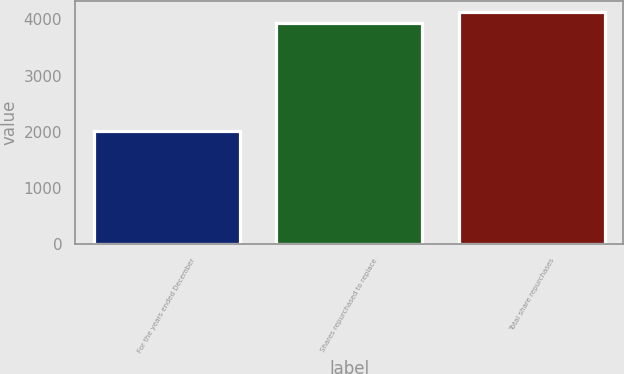<chart> <loc_0><loc_0><loc_500><loc_500><bar_chart><fcel>For the years ended December<fcel>Shares repurchased to replace<fcel>Total share repurchases<nl><fcel>2010<fcel>3932<fcel>4124.2<nl></chart> 